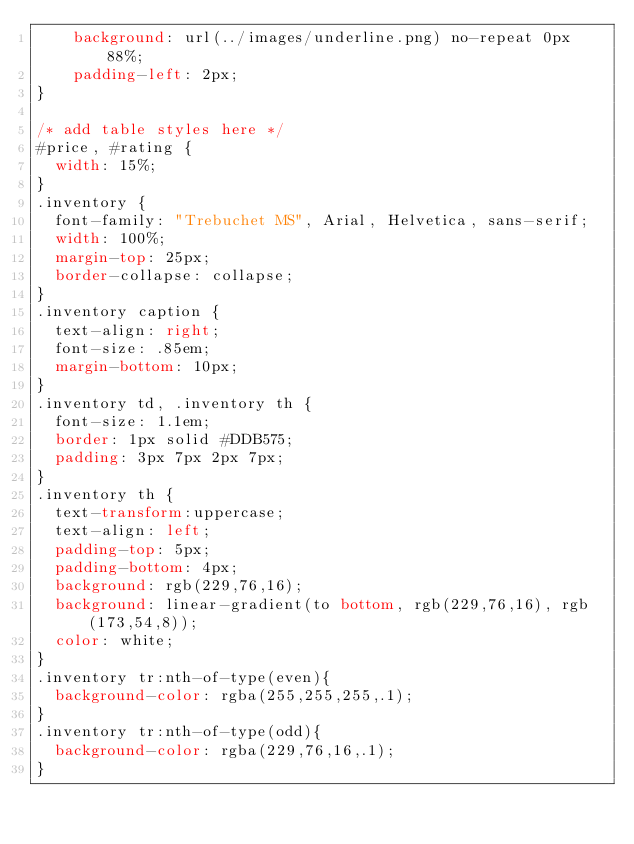<code> <loc_0><loc_0><loc_500><loc_500><_CSS_>	background: url(../images/underline.png) no-repeat 0px 88%;
	padding-left: 2px;
}

/* add table styles here */
#price, #rating {
  width: 15%;
}
.inventory {
  font-family: "Trebuchet MS", Arial, Helvetica, sans-serif;
  width: 100%;
  margin-top: 25px;
  border-collapse: collapse;
}
.inventory caption {
  text-align: right;
  font-size: .85em;
  margin-bottom: 10px;
}
.inventory td, .inventory th {
  font-size: 1.1em;
  border: 1px solid #DDB575;
  padding: 3px 7px 2px 7px;
}
.inventory th {
  text-transform:uppercase;
  text-align: left;
  padding-top: 5px;
  padding-bottom: 4px;
  background: rgb(229,76,16);
  background: linear-gradient(to bottom, rgb(229,76,16), rgb(173,54,8));
  color: white;
}
.inventory tr:nth-of-type(even){
  background-color: rgba(255,255,255,.1);
}
.inventory tr:nth-of-type(odd){
  background-color: rgba(229,76,16,.1);
}


</code> 